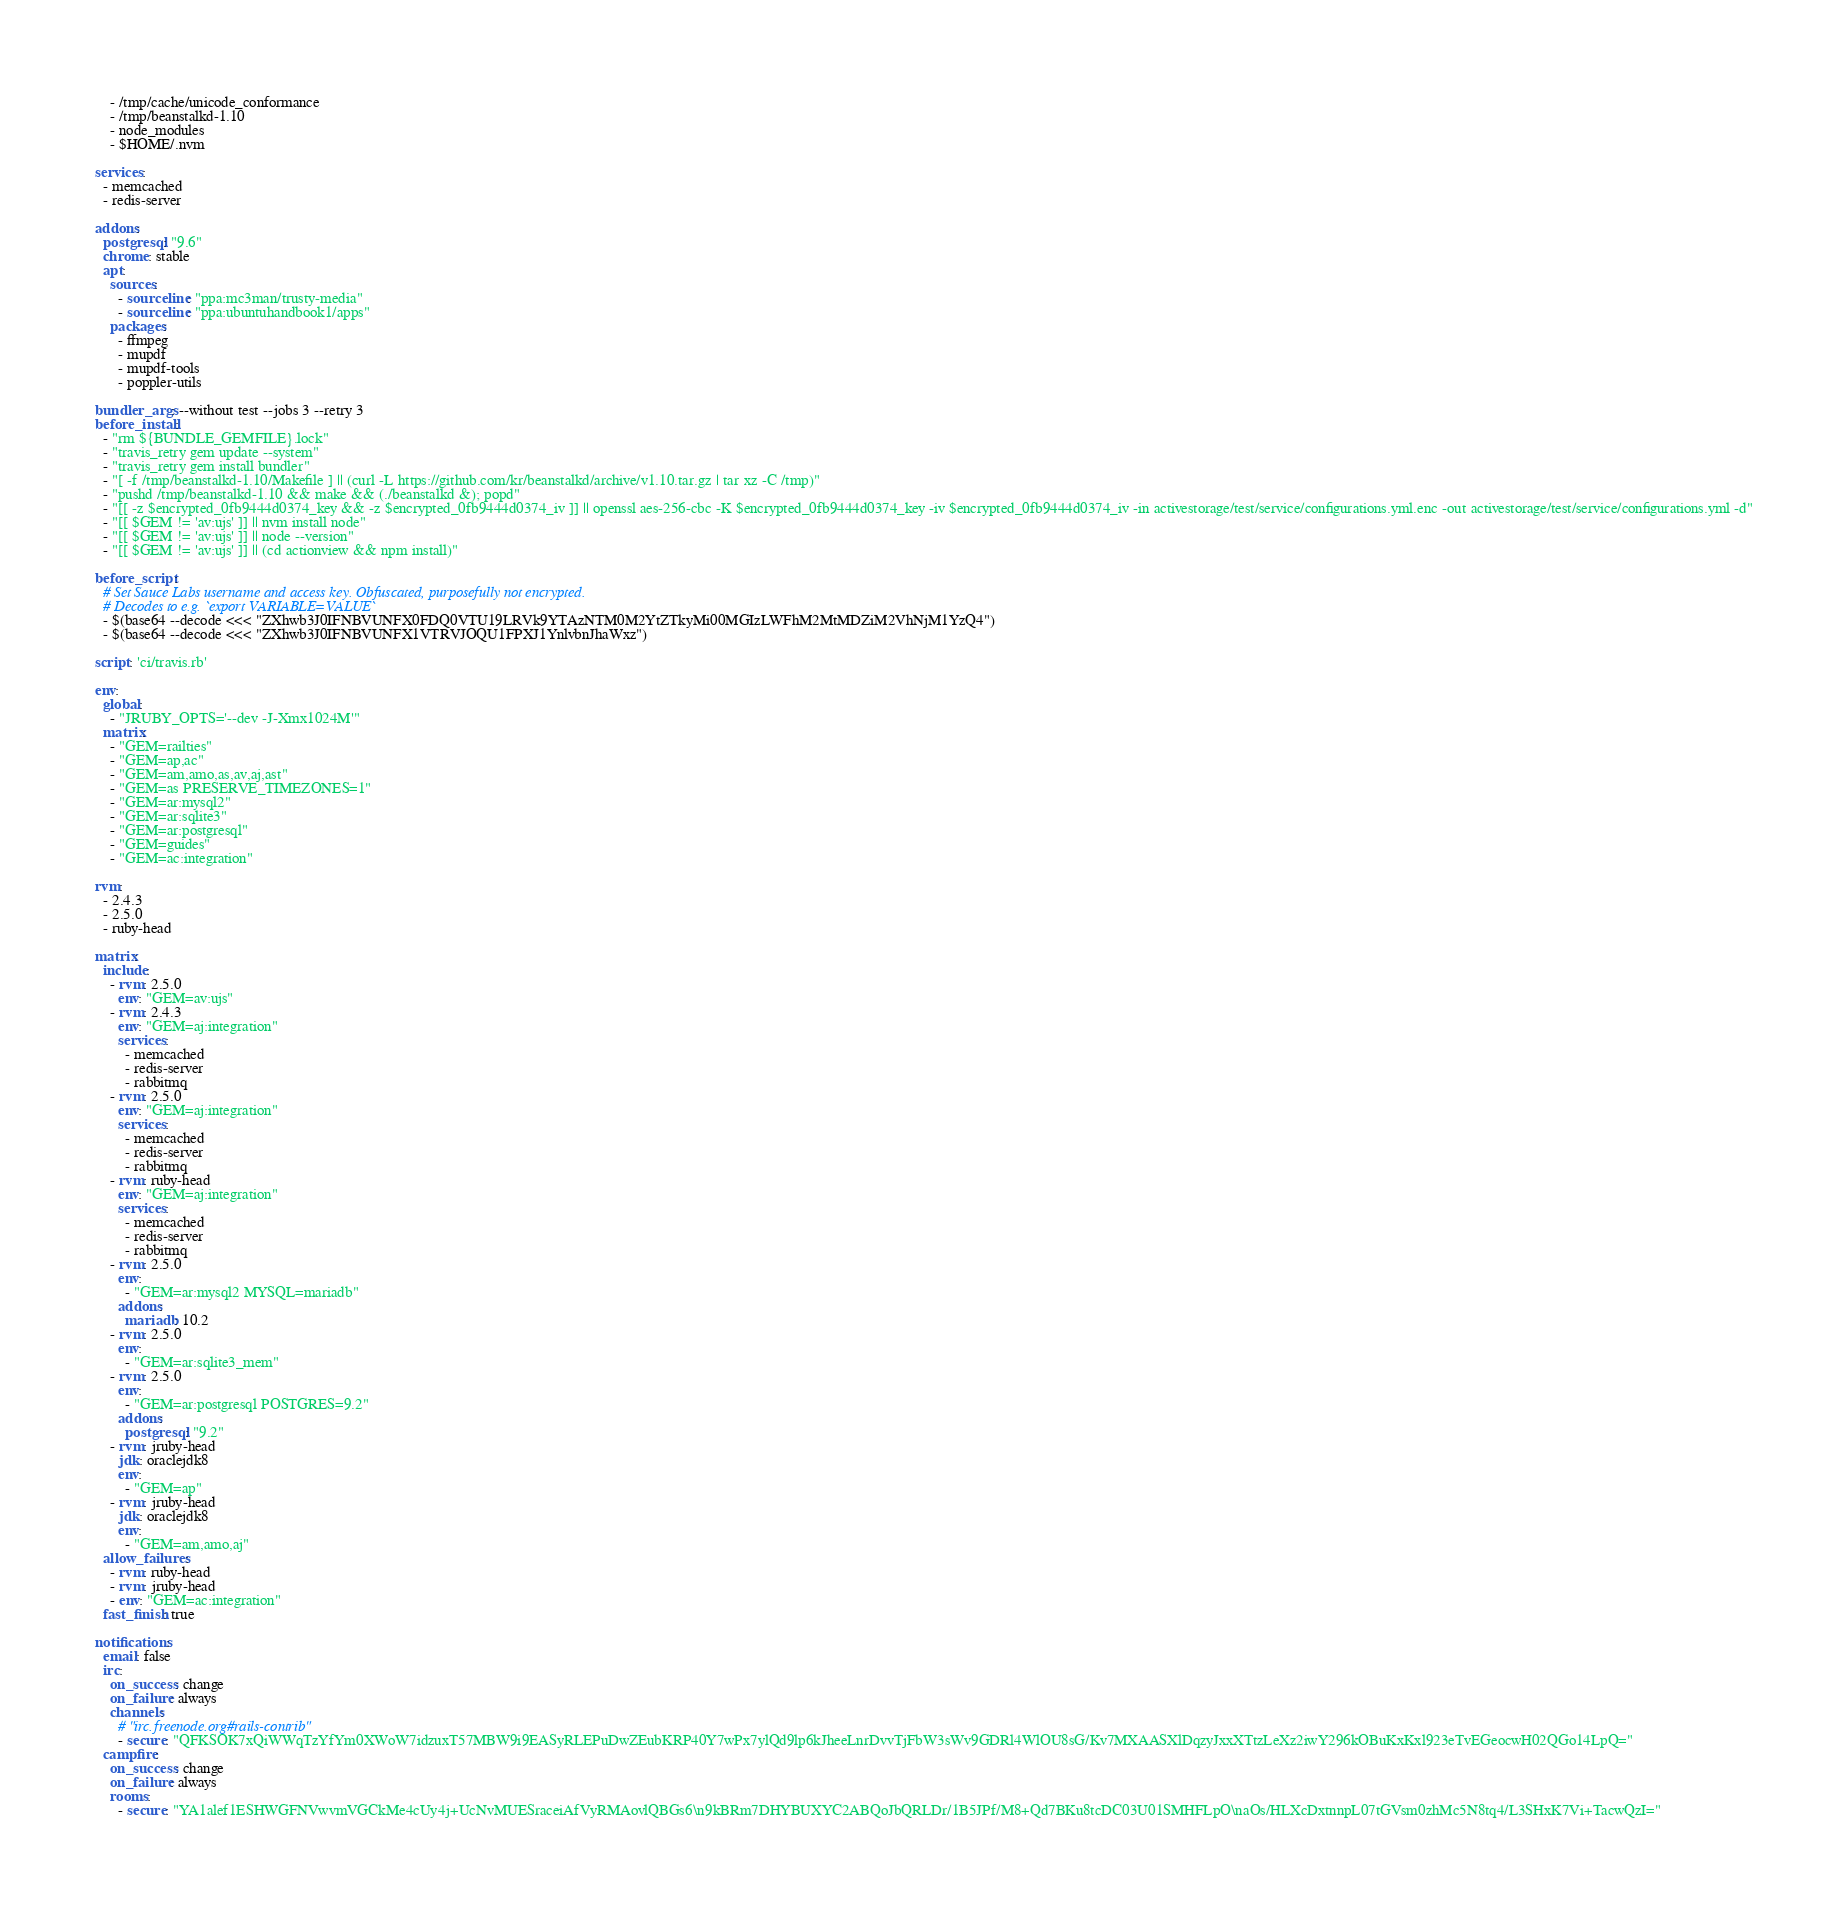<code> <loc_0><loc_0><loc_500><loc_500><_YAML_>    - /tmp/cache/unicode_conformance
    - /tmp/beanstalkd-1.10
    - node_modules
    - $HOME/.nvm

services:
  - memcached
  - redis-server

addons:
  postgresql: "9.6"
  chrome: stable
  apt:
    sources:
      - sourceline: "ppa:mc3man/trusty-media"
      - sourceline: "ppa:ubuntuhandbook1/apps"
    packages:
      - ffmpeg
      - mupdf
      - mupdf-tools
      - poppler-utils

bundler_args: --without test --jobs 3 --retry 3
before_install:
  - "rm ${BUNDLE_GEMFILE}.lock"
  - "travis_retry gem update --system"
  - "travis_retry gem install bundler"
  - "[ -f /tmp/beanstalkd-1.10/Makefile ] || (curl -L https://github.com/kr/beanstalkd/archive/v1.10.tar.gz | tar xz -C /tmp)"
  - "pushd /tmp/beanstalkd-1.10 && make && (./beanstalkd &); popd"
  - "[[ -z $encrypted_0fb9444d0374_key && -z $encrypted_0fb9444d0374_iv ]] || openssl aes-256-cbc -K $encrypted_0fb9444d0374_key -iv $encrypted_0fb9444d0374_iv -in activestorage/test/service/configurations.yml.enc -out activestorage/test/service/configurations.yml -d"
  - "[[ $GEM != 'av:ujs' ]] || nvm install node"
  - "[[ $GEM != 'av:ujs' ]] || node --version"
  - "[[ $GEM != 'av:ujs' ]] || (cd actionview && npm install)"

before_script:
  # Set Sauce Labs username and access key. Obfuscated, purposefully not encrypted.
  # Decodes to e.g. `export VARIABLE=VALUE`
  - $(base64 --decode <<< "ZXhwb3J0IFNBVUNFX0FDQ0VTU19LRVk9YTAzNTM0M2YtZTkyMi00MGIzLWFhM2MtMDZiM2VhNjM1YzQ4")
  - $(base64 --decode <<< "ZXhwb3J0IFNBVUNFX1VTRVJOQU1FPXJ1YnlvbnJhaWxz")

script: 'ci/travis.rb'

env:
  global:
    - "JRUBY_OPTS='--dev -J-Xmx1024M'"
  matrix:
    - "GEM=railties"
    - "GEM=ap,ac"
    - "GEM=am,amo,as,av,aj,ast"
    - "GEM=as PRESERVE_TIMEZONES=1"
    - "GEM=ar:mysql2"
    - "GEM=ar:sqlite3"
    - "GEM=ar:postgresql"
    - "GEM=guides"
    - "GEM=ac:integration"

rvm:
  - 2.4.3
  - 2.5.0
  - ruby-head

matrix:
  include:
    - rvm: 2.5.0
      env: "GEM=av:ujs"
    - rvm: 2.4.3
      env: "GEM=aj:integration"
      services:
        - memcached
        - redis-server
        - rabbitmq
    - rvm: 2.5.0
      env: "GEM=aj:integration"
      services:
        - memcached
        - redis-server
        - rabbitmq
    - rvm: ruby-head
      env: "GEM=aj:integration"
      services:
        - memcached
        - redis-server
        - rabbitmq
    - rvm: 2.5.0
      env:
        - "GEM=ar:mysql2 MYSQL=mariadb"
      addons:
        mariadb: 10.2
    - rvm: 2.5.0
      env:
        - "GEM=ar:sqlite3_mem"
    - rvm: 2.5.0
      env:
        - "GEM=ar:postgresql POSTGRES=9.2"
      addons:
        postgresql: "9.2"
    - rvm: jruby-head
      jdk: oraclejdk8
      env:
        - "GEM=ap"
    - rvm: jruby-head
      jdk: oraclejdk8
      env:
        - "GEM=am,amo,aj"
  allow_failures:
    - rvm: ruby-head
    - rvm: jruby-head
    - env: "GEM=ac:integration"
  fast_finish: true

notifications:
  email: false
  irc:
    on_success: change
    on_failure: always
    channels:
      # "irc.freenode.org#rails-contrib"
      - secure: "QFKSOK7xQiWWqTzYfYm0XWoW7idzuxT57MBW9i9EASyRLEPuDwZEubKRP40Y7wPx7ylQd9lp6kJheeLnrDvvTjFbW3sWv9GDRl4WlOU8sG/Kv7MXAASXlDqzyJxxXTtzLeXz2iwY296kOBuKxKxl923eTvEGeocwH02QGo14LpQ="
  campfire:
    on_success: change
    on_failure: always
    rooms:
      - secure: "YA1alef1ESHWGFNVwvmVGCkMe4cUy4j+UcNvMUESraceiAfVyRMAovlQBGs6\n9kBRm7DHYBUXYC2ABQoJbQRLDr/1B5JPf/M8+Qd7BKu8tcDC03U01SMHFLpO\naOs/HLXcDxtnnpL07tGVsm0zhMc5N8tq4/L3SHxK7Vi+TacwQzI="
</code> 